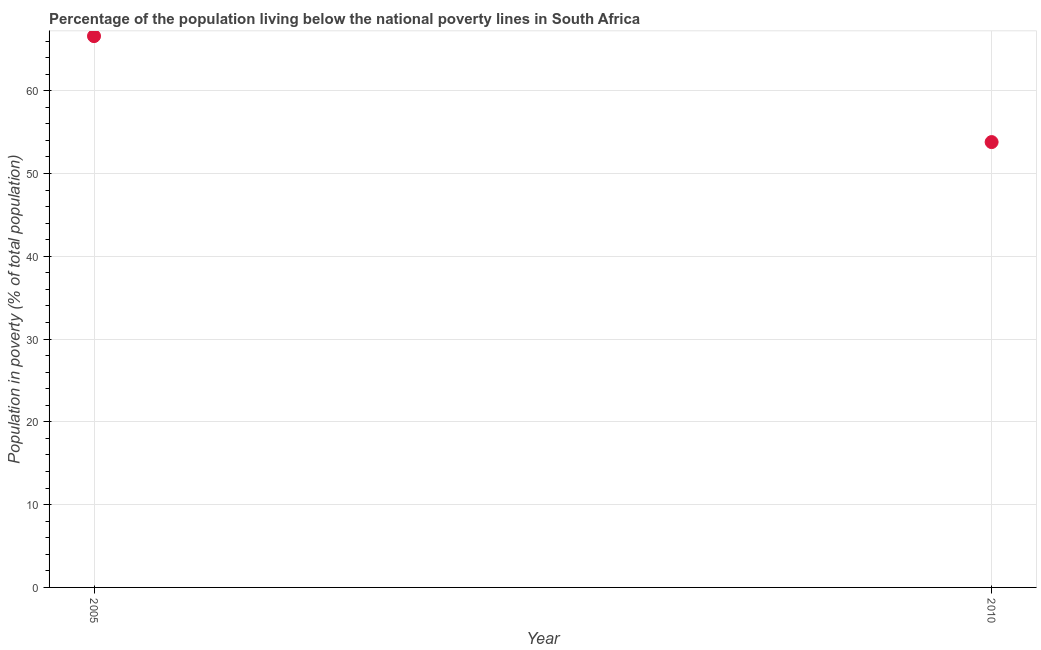What is the percentage of population living below poverty line in 2010?
Offer a very short reply. 53.8. Across all years, what is the maximum percentage of population living below poverty line?
Your answer should be compact. 66.6. Across all years, what is the minimum percentage of population living below poverty line?
Your answer should be compact. 53.8. In which year was the percentage of population living below poverty line minimum?
Make the answer very short. 2010. What is the sum of the percentage of population living below poverty line?
Ensure brevity in your answer.  120.4. What is the difference between the percentage of population living below poverty line in 2005 and 2010?
Offer a very short reply. 12.8. What is the average percentage of population living below poverty line per year?
Your answer should be very brief. 60.2. What is the median percentage of population living below poverty line?
Ensure brevity in your answer.  60.2. Do a majority of the years between 2010 and 2005 (inclusive) have percentage of population living below poverty line greater than 48 %?
Provide a short and direct response. No. What is the ratio of the percentage of population living below poverty line in 2005 to that in 2010?
Your response must be concise. 1.24. Is the percentage of population living below poverty line in 2005 less than that in 2010?
Your response must be concise. No. Does the percentage of population living below poverty line monotonically increase over the years?
Provide a succinct answer. No. Does the graph contain any zero values?
Your response must be concise. No. What is the title of the graph?
Provide a succinct answer. Percentage of the population living below the national poverty lines in South Africa. What is the label or title of the Y-axis?
Offer a very short reply. Population in poverty (% of total population). What is the Population in poverty (% of total population) in 2005?
Offer a very short reply. 66.6. What is the Population in poverty (% of total population) in 2010?
Provide a short and direct response. 53.8. What is the difference between the Population in poverty (% of total population) in 2005 and 2010?
Your response must be concise. 12.8. What is the ratio of the Population in poverty (% of total population) in 2005 to that in 2010?
Offer a terse response. 1.24. 